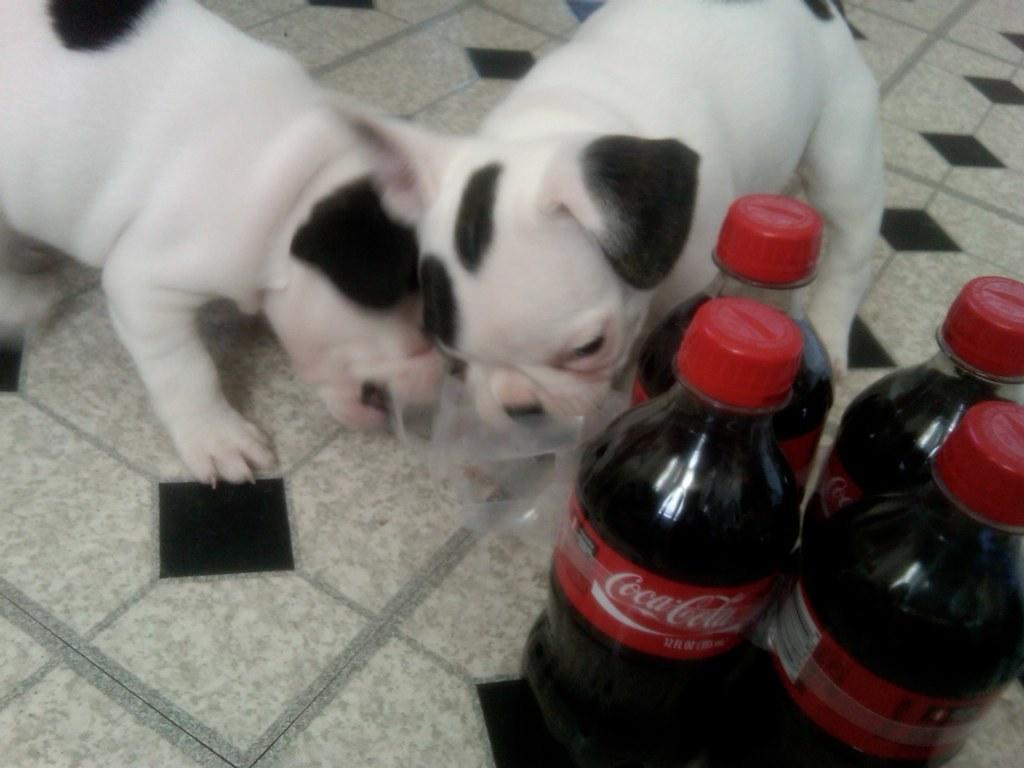Could you give a brief overview of what you see in this image? In this image I can see two dogs. On the right side, I can see the cool drink bottles. 